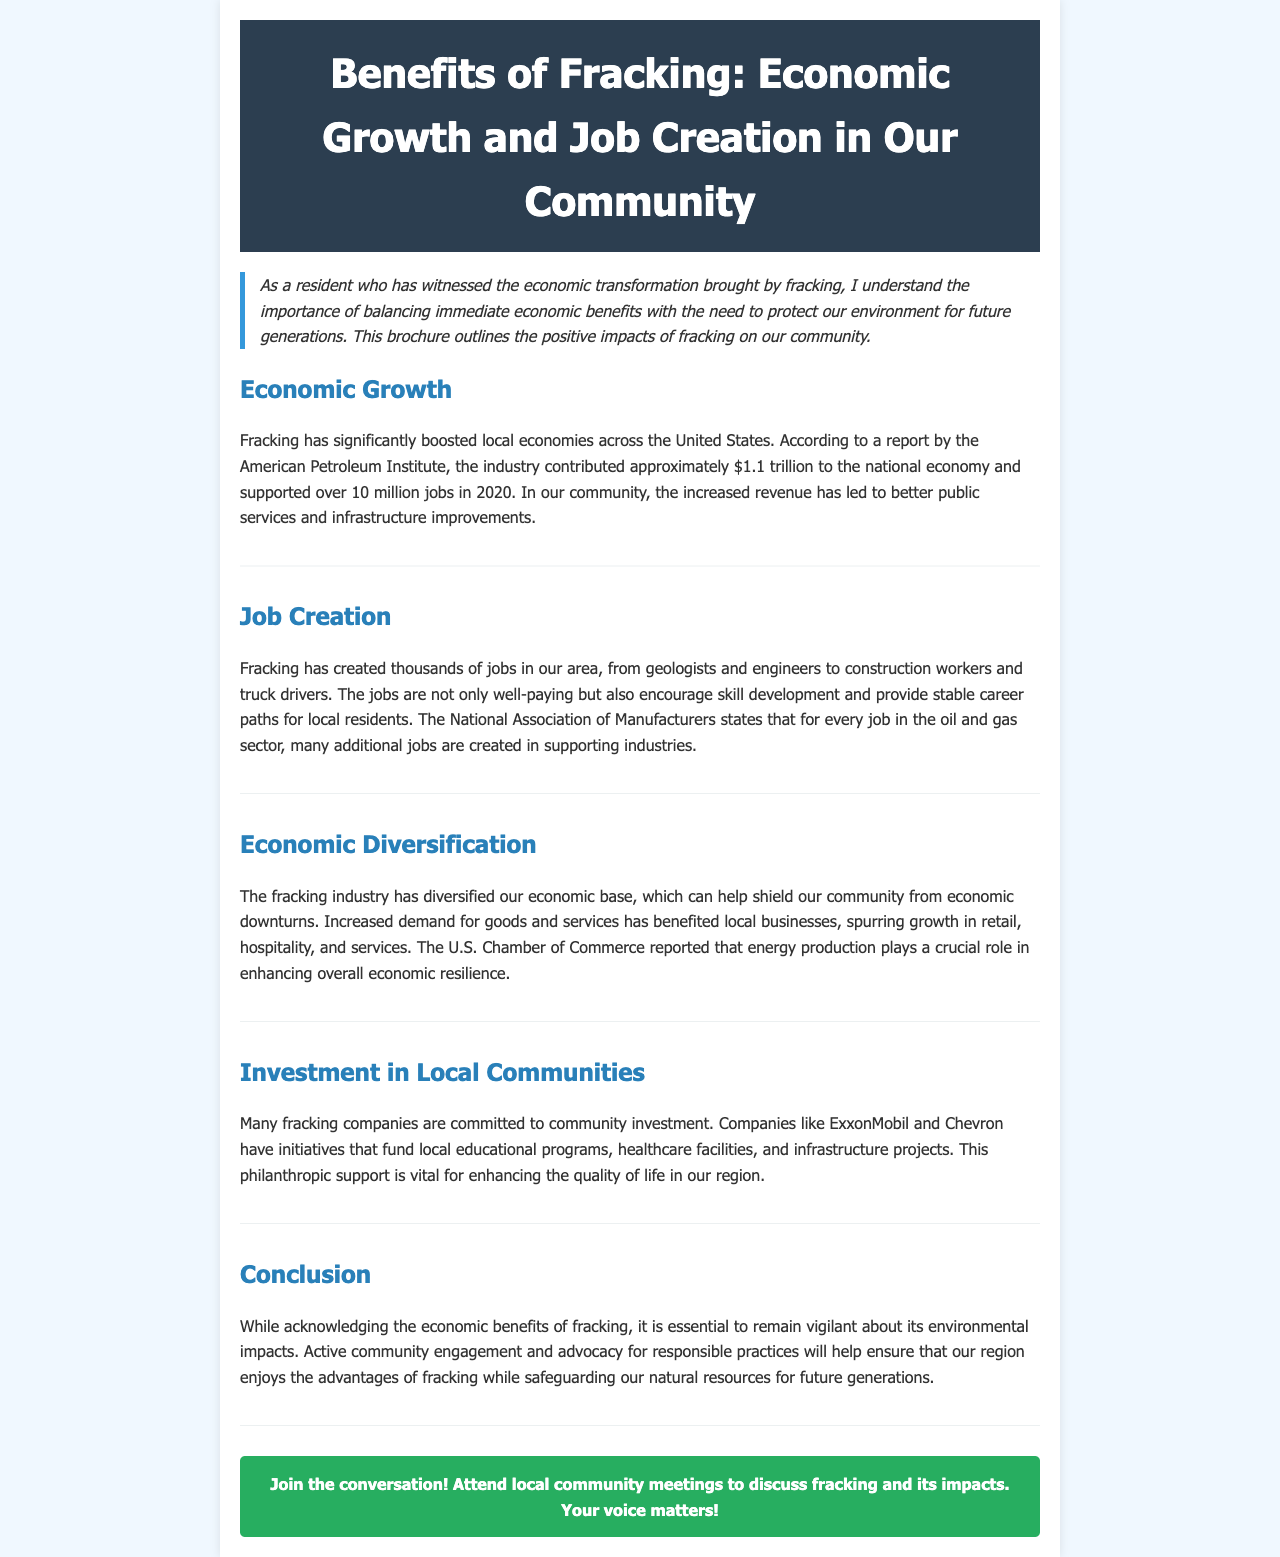What is the economic contribution of the fracking industry? The fracking industry contributed approximately $1.1 trillion to the national economy.
Answer: $1.1 trillion How many jobs did the fracking industry support in 2020? The fracking industry supported over 10 million jobs in 2020.
Answer: 10 million What types of jobs have been created by fracking in our area? The document lists jobs like geologists, engineers, construction workers, and truck drivers.
Answer: Geologists, engineers, construction workers, truck drivers Which organizations are mentioned as sources for job creation and economic effects? The organizations mentioned include the American Petroleum Institute and the National Association of Manufacturers.
Answer: American Petroleum Institute, National Association of Manufacturers What industries have benefited from the diversification due to fracking? The sectors that have benefited include retail, hospitality, and services.
Answer: Retail, hospitality, services Which companies are highlighted for their community investment efforts? The companies mentioned are ExxonMobil and Chevron.
Answer: ExxonMobil, Chevron What call to action is included in the brochure? The call to action encourages attending local community meetings to discuss fracking.
Answer: Attend local community meetings What should we remain vigilant about, according to the conclusion? The conclusion emphasizes the need to remain vigilant about environmental impacts.
Answer: Environmental impacts 